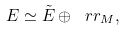<formula> <loc_0><loc_0><loc_500><loc_500>E \simeq \tilde { E } \oplus \ r r _ { M } ,</formula> 